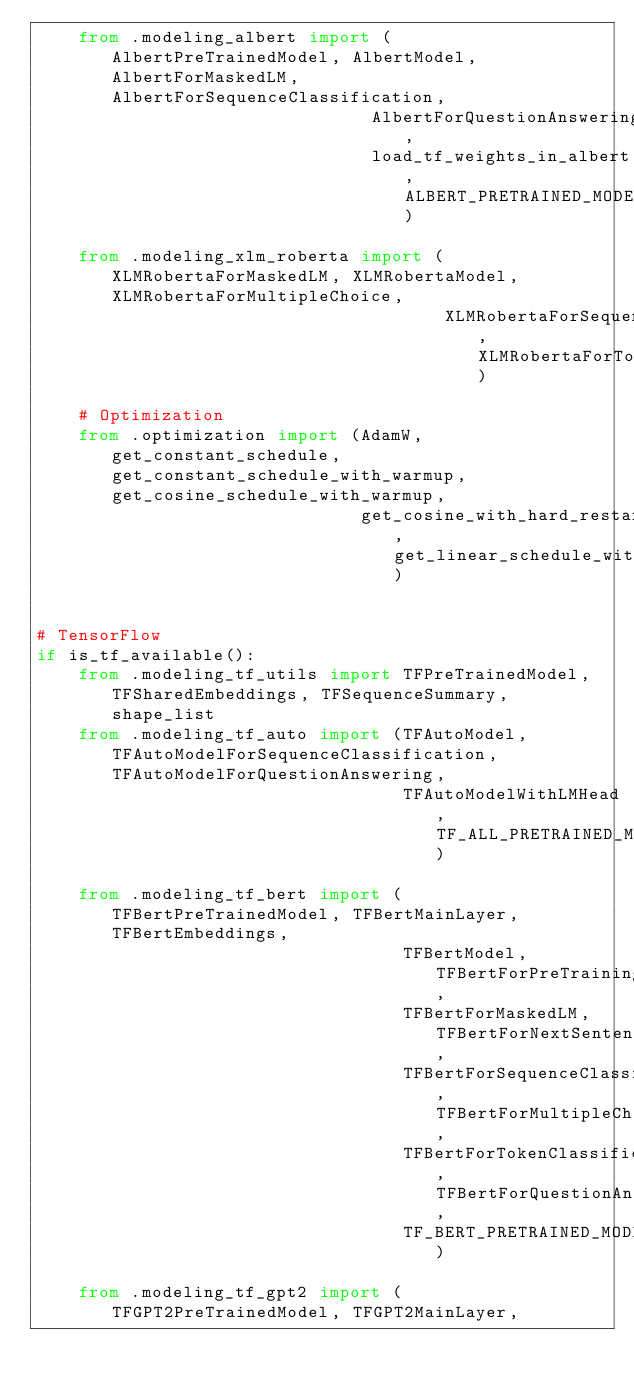<code> <loc_0><loc_0><loc_500><loc_500><_Python_>    from .modeling_albert import (AlbertPreTrainedModel, AlbertModel, AlbertForMaskedLM, AlbertForSequenceClassification,
                                AlbertForQuestionAnswering,
                                load_tf_weights_in_albert, ALBERT_PRETRAINED_MODEL_ARCHIVE_MAP)

    from .modeling_xlm_roberta import (XLMRobertaForMaskedLM, XLMRobertaModel, XLMRobertaForMultipleChoice,
                                       XLMRobertaForSequenceClassification, XLMRobertaForTokenClassification)

    # Optimization
    from .optimization import (AdamW, get_constant_schedule, get_constant_schedule_with_warmup, get_cosine_schedule_with_warmup,
                               get_cosine_with_hard_restarts_schedule_with_warmup, get_linear_schedule_with_warmup)


# TensorFlow
if is_tf_available():
    from .modeling_tf_utils import TFPreTrainedModel, TFSharedEmbeddings, TFSequenceSummary, shape_list
    from .modeling_tf_auto import (TFAutoModel, TFAutoModelForSequenceClassification, TFAutoModelForQuestionAnswering,
                                   TFAutoModelWithLMHead, TF_ALL_PRETRAINED_MODEL_ARCHIVE_MAP)

    from .modeling_tf_bert import (TFBertPreTrainedModel, TFBertMainLayer, TFBertEmbeddings,
                                   TFBertModel, TFBertForPreTraining,
                                   TFBertForMaskedLM, TFBertForNextSentencePrediction,
                                   TFBertForSequenceClassification, TFBertForMultipleChoice,
                                   TFBertForTokenClassification, TFBertForQuestionAnswering,
                                   TF_BERT_PRETRAINED_MODEL_ARCHIVE_MAP)

    from .modeling_tf_gpt2 import (TFGPT2PreTrainedModel, TFGPT2MainLayer,</code> 